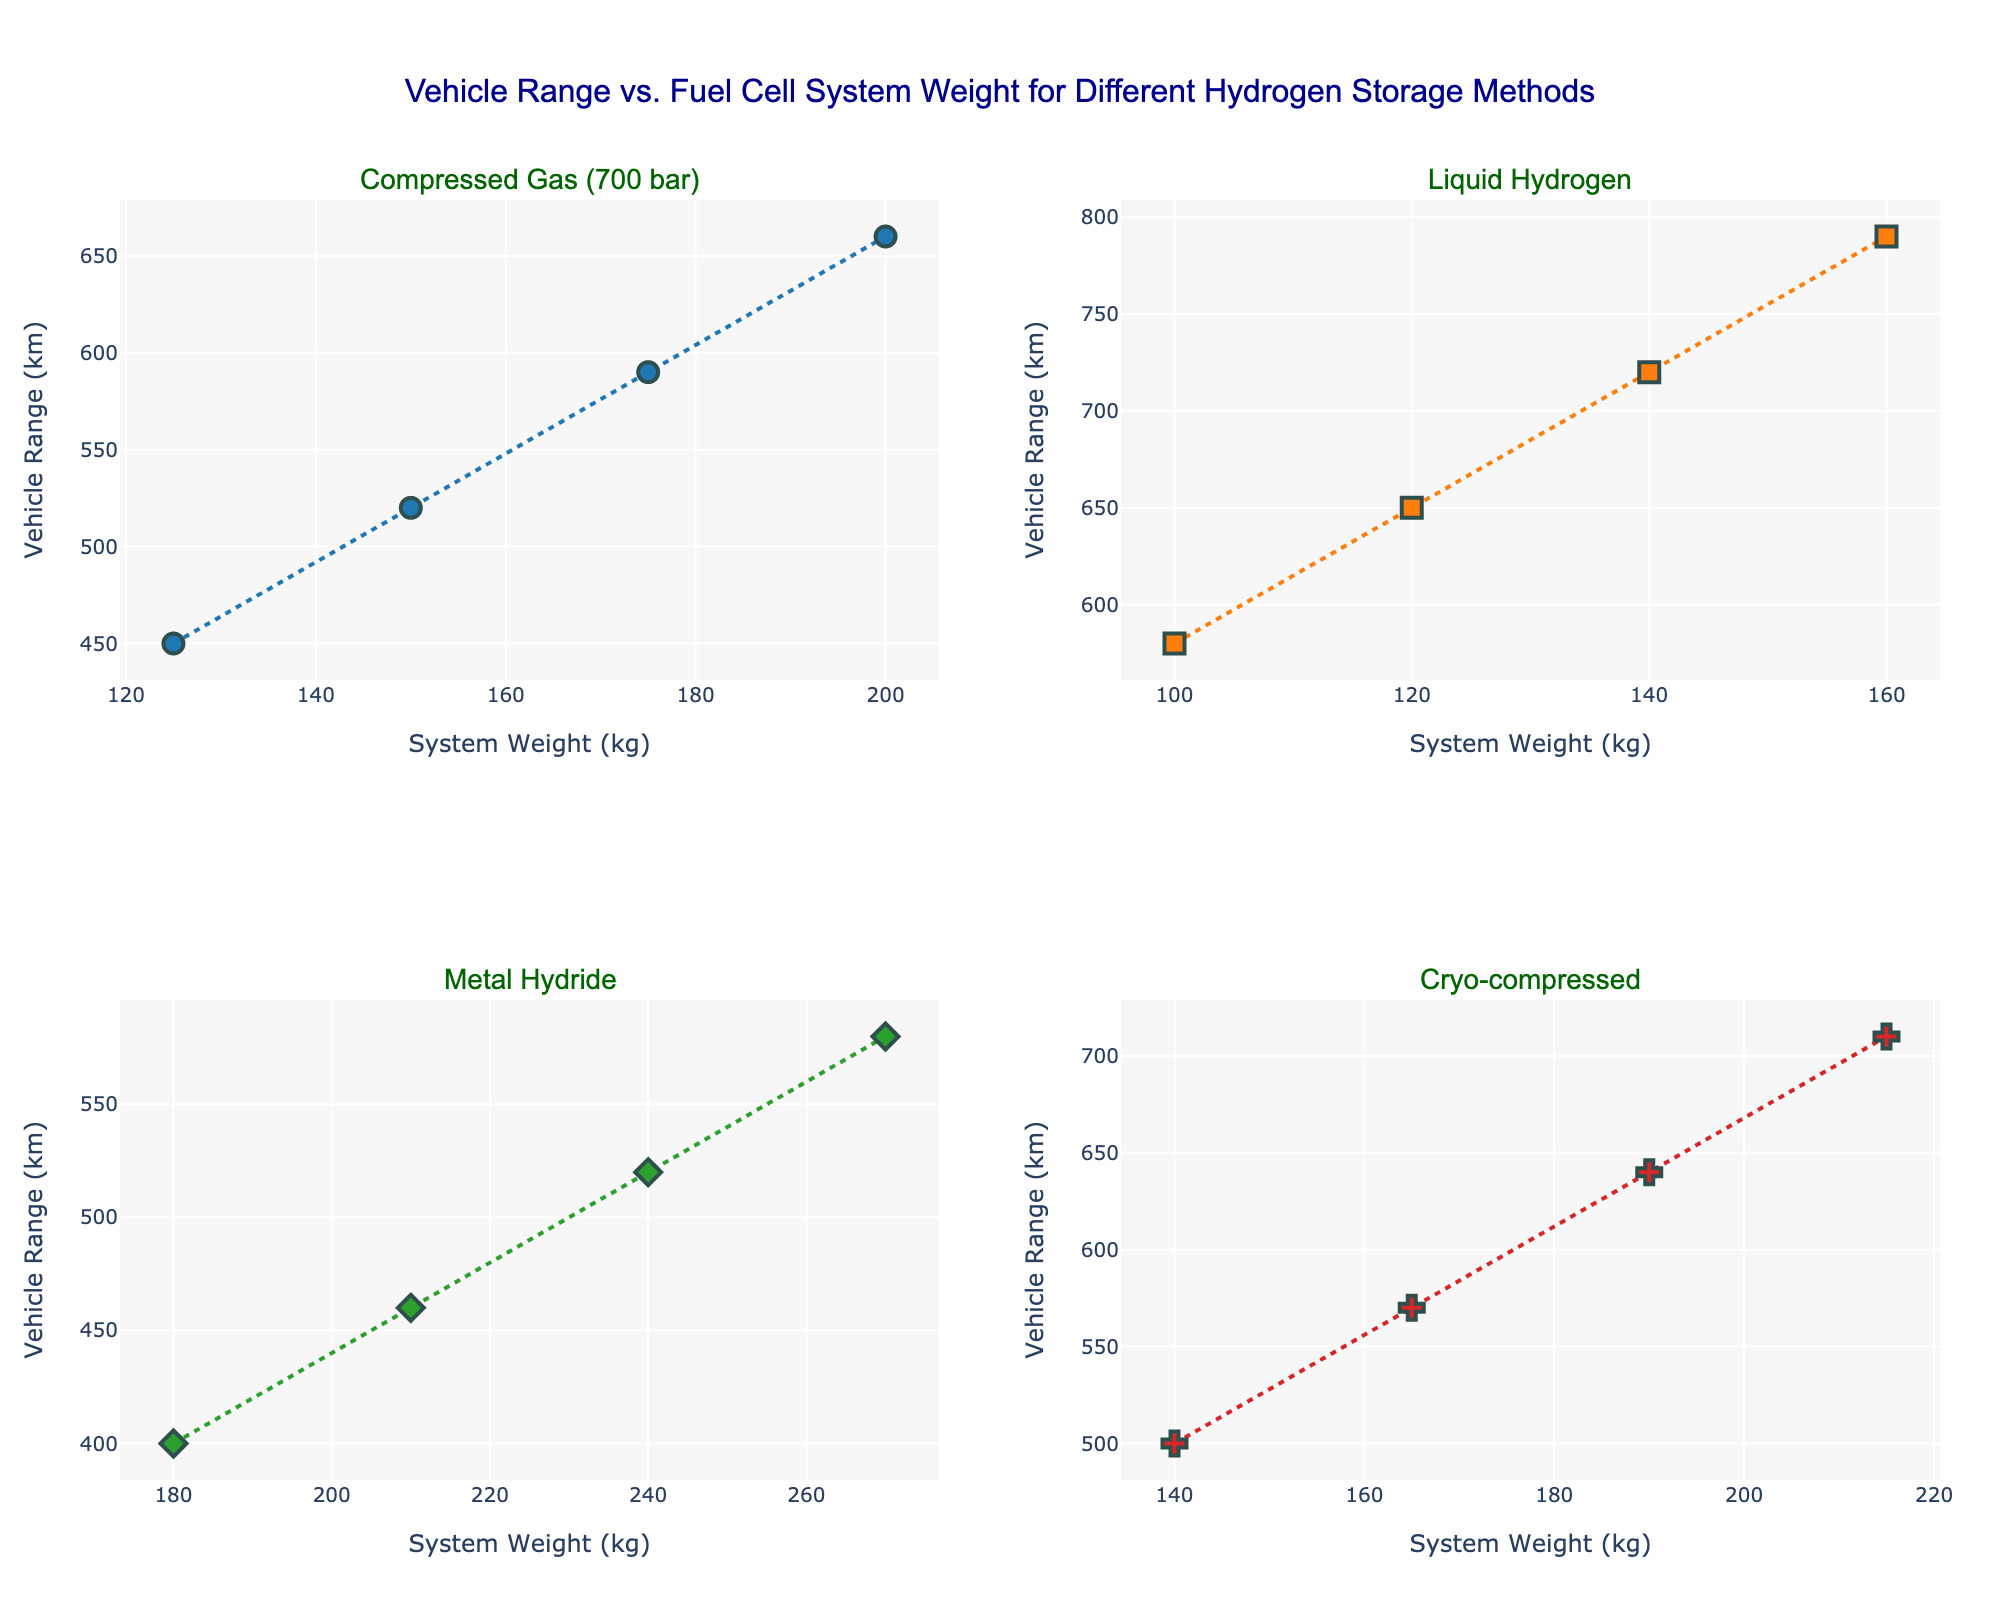What's the title of the figure? The title of the figure is usually located at the top center of the plot. It provides a summary of what the figure represents.
Answer: Vehicle Range vs. Fuel Cell System Weight for Different Hydrogen Storage Methods How many different hydrogen storage methods are compared in the figure? The figure has subplots for each unique storage method, and the subplot titles indicate these methods. By counting them, we can determine there are four methods.
Answer: 4 Which storage method shows the highest vehicle range? By looking at the y-axis values in each subplot, the method with the highest value will indicate the highest vehicle range. Liquid Hydrogen's subplot has the highest plot points on the y-axis.
Answer: Liquid Hydrogen Which storage method has the system weight range starting from 100 kg? The x-axis represents the system weight for each subplot. The subplot for Liquid Hydrogen shows data starting from 100 kg.
Answer: Liquid Hydrogen How does the vehicle range change with system weight for Compressed Gas (700 bar)? The subplot for Compressed Gas (700 bar) shows that as the system weight increases along the x-axis, the vehicle range increases along the y-axis.
Answer: Increases What's the difference in maximum vehicle range between Liquid Hydrogen and Metal Hydride storage methods? The maximum vehicle range for Liquid Hydrogen is 790 km, while for Metal Hydride it is 580 km. Subtracting the two gives the difference: 790 - 580.
Answer: 210 km Compare the trends between Cryo-compressed and Metal Hydride storage methods. Both subplots show a positive trend as system weight increases, but Cryo-compressed reaches a higher maximum vehicle range compared to Metal Hydride.
Answer: Cryo-compressed reaches higher range Which storage method demonstrates the smallest increase in vehicle range as system weight increases? By comparing the slopes of the lines in each subplot, the Metal Hydride subplot shows the smallest increase in range as system weight increases.
Answer: Metal Hydride What is the vehicle range for Liquid Hydrogen at a system weight of 140 kg? By locating 140 kg on the x-axis of the Liquid Hydrogen subplot and finding the corresponding y-axis value, we see the vehicle range is 720 km.
Answer: 720 km 